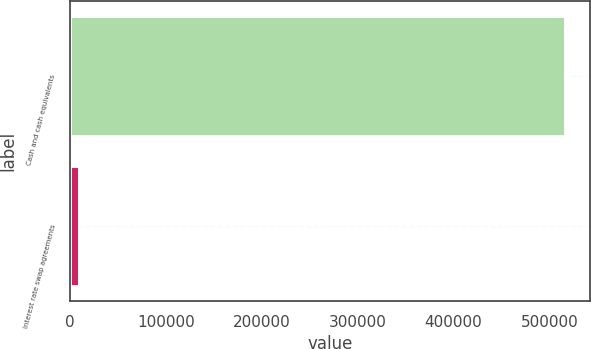Convert chart. <chart><loc_0><loc_0><loc_500><loc_500><bar_chart><fcel>Cash and cash equivalents<fcel>Interest rate swap agreements<nl><fcel>516172<fcel>9911<nl></chart> 